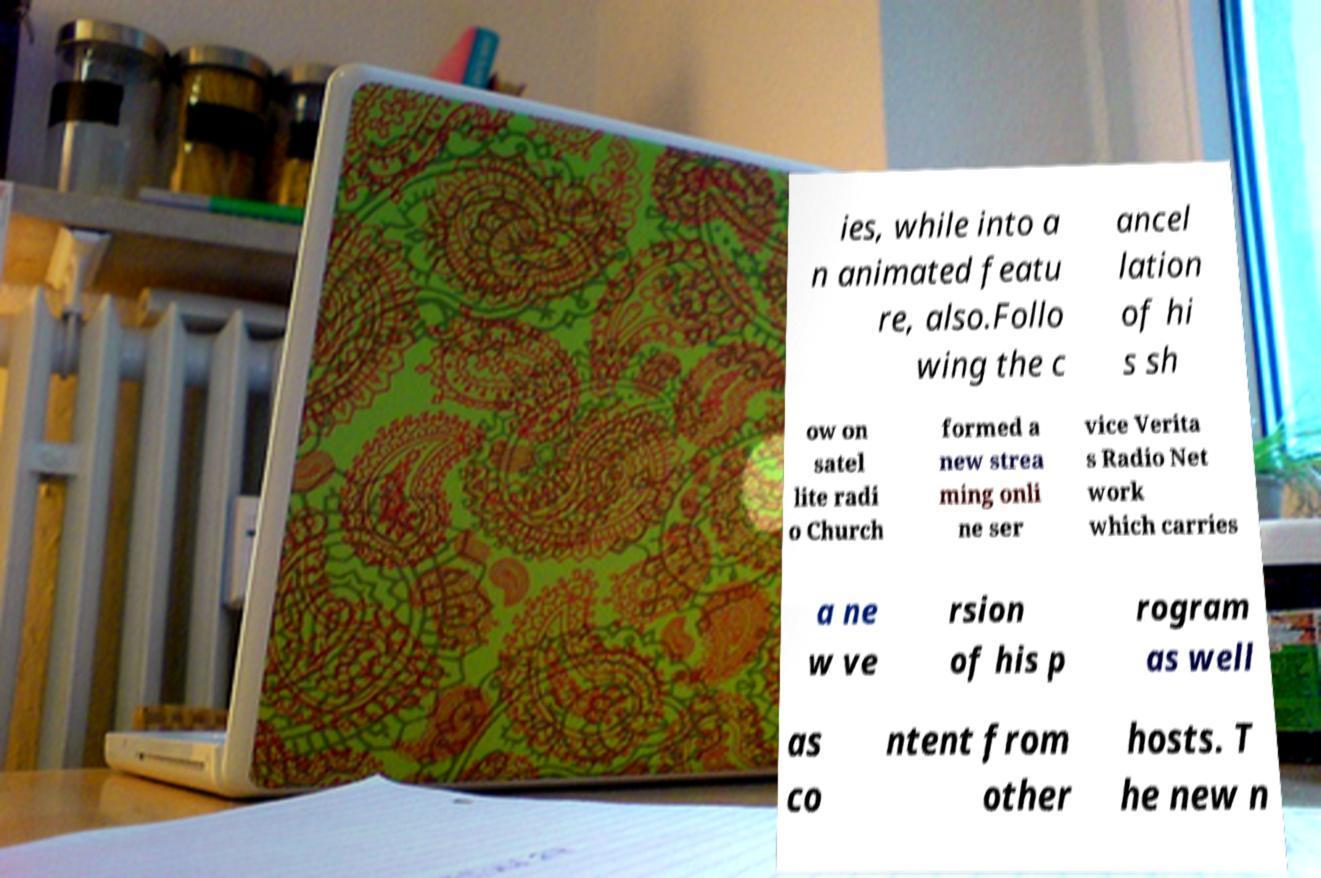Can you accurately transcribe the text from the provided image for me? ies, while into a n animated featu re, also.Follo wing the c ancel lation of hi s sh ow on satel lite radi o Church formed a new strea ming onli ne ser vice Verita s Radio Net work which carries a ne w ve rsion of his p rogram as well as co ntent from other hosts. T he new n 